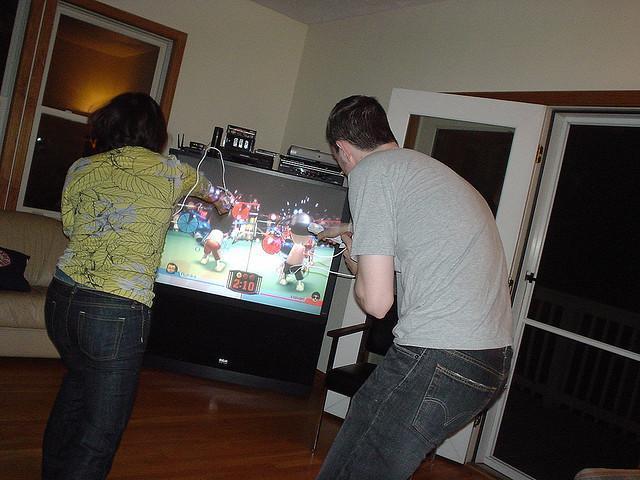How many people are there?
Give a very brief answer. 2. How many red bikes are there?
Give a very brief answer. 0. 